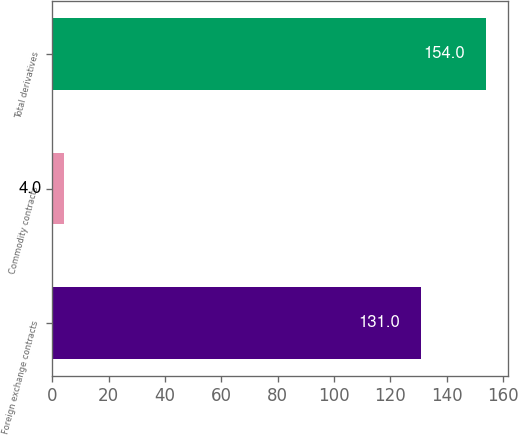<chart> <loc_0><loc_0><loc_500><loc_500><bar_chart><fcel>Foreign exchange contracts<fcel>Commodity contracts<fcel>Total derivatives<nl><fcel>131<fcel>4<fcel>154<nl></chart> 